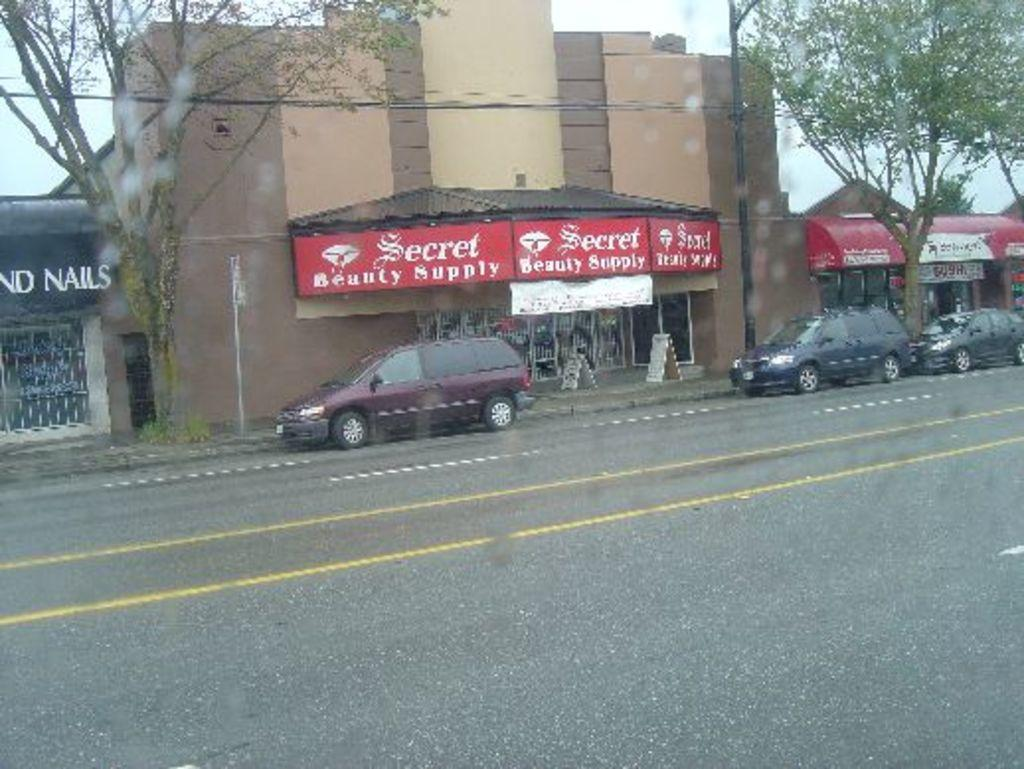What type of establishment is shown in the image? There is a store in the image. Can you describe any text or signage on the store? The store has some text on it. What else can be seen in the image besides the store? There are cars, trees, and a road in the image. What is visible in the background of the image? The sky is visible in the background of the image. Where are the honey and stick located in the image? There is no honey or stick present in the image. How many balls can be seen in the image? There are no balls visible in the image. 